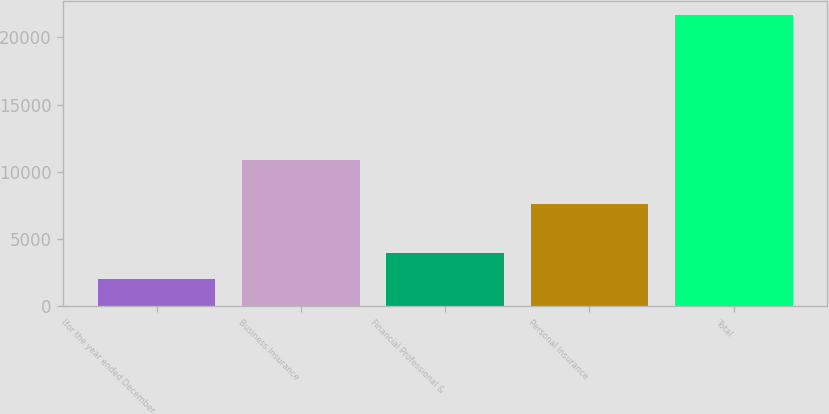<chart> <loc_0><loc_0><loc_500><loc_500><bar_chart><fcel>(for the year ended December<fcel>Business Insurance<fcel>Financial Professional &<fcel>Personal Insurance<fcel>Total<nl><fcel>2010<fcel>10857<fcel>3972.5<fcel>7567<fcel>21635<nl></chart> 